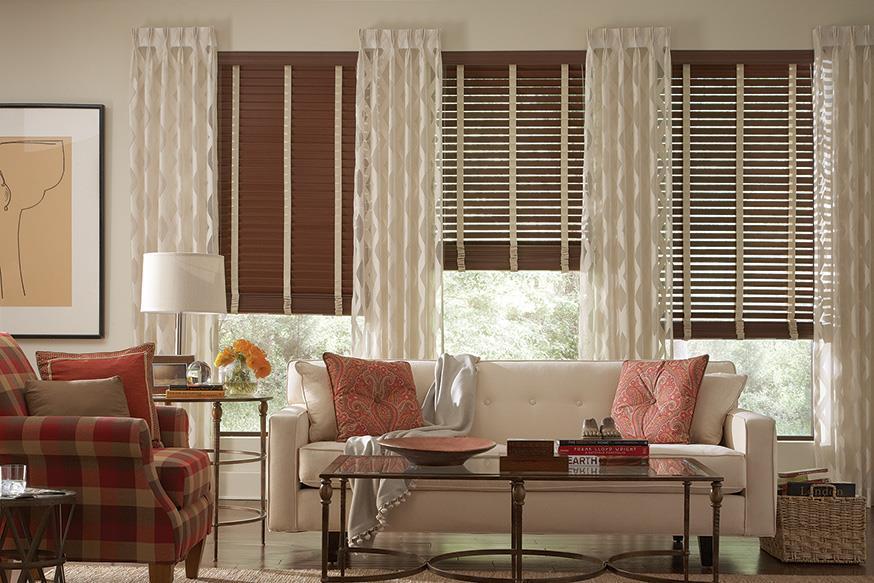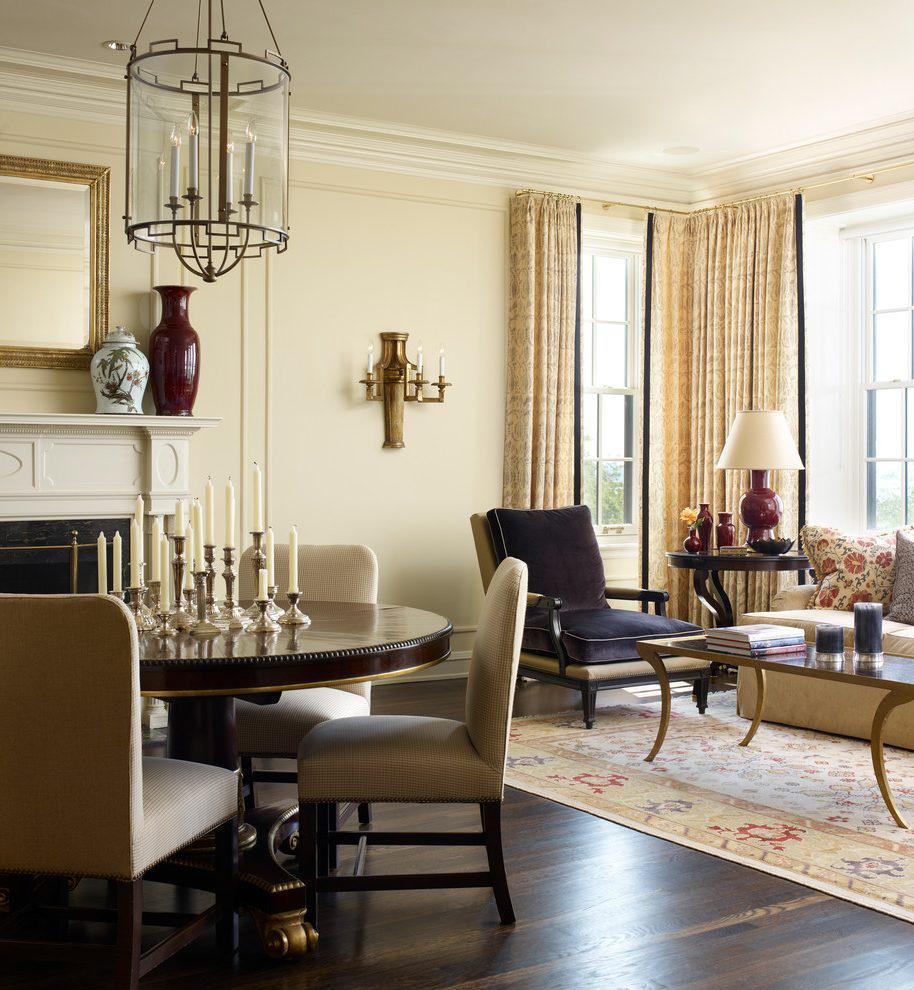The first image is the image on the left, the second image is the image on the right. Assess this claim about the two images: "Shades are at least partially open in both images.". Correct or not? Answer yes or no. Yes. The first image is the image on the left, the second image is the image on the right. Examine the images to the left and right. Is the description "An image shows a room with dark-colored walls and at least four brown shades on windows with light-colored frames and no drapes." accurate? Answer yes or no. No. 